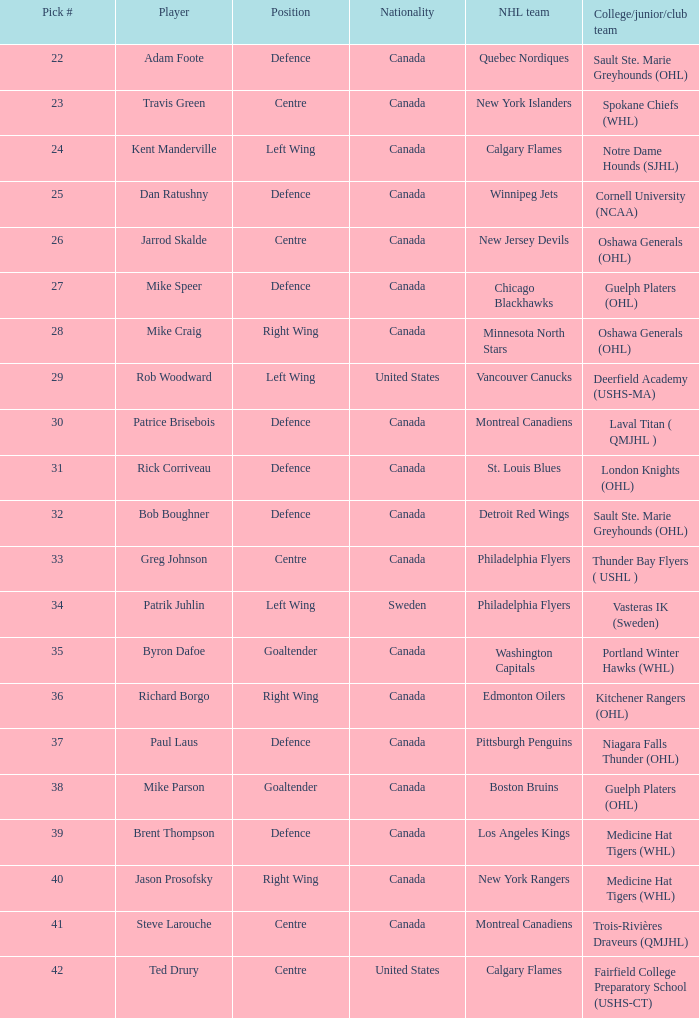What is the nationality of the draft pick player who plays centre position and is going to Calgary Flames? United States. 